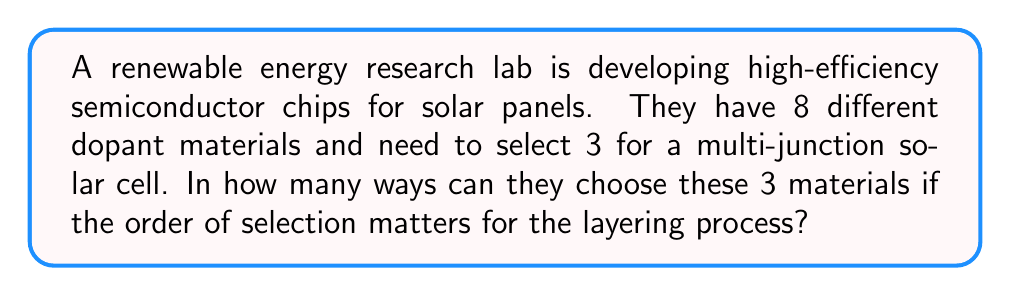Show me your answer to this math problem. To solve this problem, we need to use the concept of permutations. Since the order of selection matters for the layering process, we are dealing with permutations rather than combinations.

The formula for permutations is:

$$P(n,r) = \frac{n!}{(n-r)!}$$

Where:
$n$ = total number of items to choose from
$r$ = number of items being chosen

In this case:
$n = 8$ (total number of dopant materials)
$r = 3$ (number of materials to be selected)

Let's substitute these values into the formula:

$$P(8,3) = \frac{8!}{(8-3)!} = \frac{8!}{5!}$$

Now, let's calculate this step-by-step:

1) $8! = 8 \times 7 \times 6 \times 5!$

2) Substituting this into our equation:
   $$\frac{8!}{5!} = \frac{8 \times 7 \times 6 \times 5!}{5!}$$

3) The $5!$ cancels out in the numerator and denominator:
   $$8 \times 7 \times 6 = 336$$

Therefore, there are 336 ways to select and arrange 3 materials out of 8 for the multi-junction solar cell.
Answer: 336 